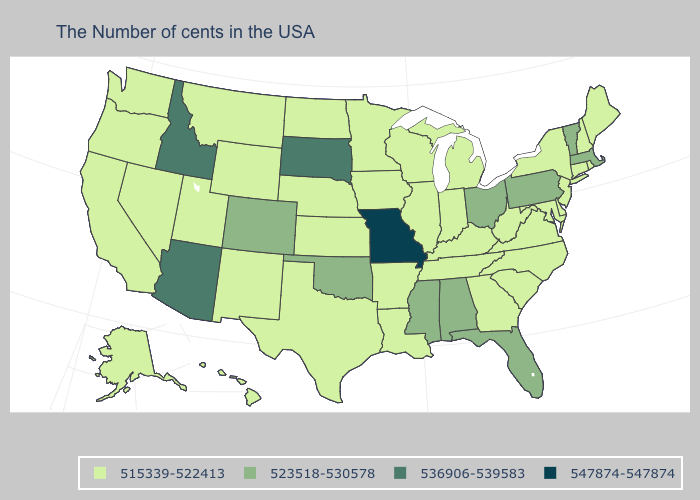Does Missouri have the highest value in the MidWest?
Be succinct. Yes. How many symbols are there in the legend?
Write a very short answer. 4. Does Texas have the same value as Arizona?
Give a very brief answer. No. Does the map have missing data?
Write a very short answer. No. Which states have the lowest value in the South?
Be succinct. Delaware, Maryland, Virginia, North Carolina, South Carolina, West Virginia, Georgia, Kentucky, Tennessee, Louisiana, Arkansas, Texas. Does Oklahoma have the highest value in the South?
Write a very short answer. Yes. Does Missouri have the highest value in the USA?
Answer briefly. Yes. Name the states that have a value in the range 523518-530578?
Write a very short answer. Massachusetts, Vermont, Pennsylvania, Ohio, Florida, Alabama, Mississippi, Oklahoma, Colorado. Does Louisiana have the lowest value in the South?
Quick response, please. Yes. Name the states that have a value in the range 536906-539583?
Write a very short answer. South Dakota, Arizona, Idaho. Does Mississippi have a lower value than Montana?
Quick response, please. No. Name the states that have a value in the range 547874-547874?
Answer briefly. Missouri. What is the value of Arkansas?
Answer briefly. 515339-522413. What is the value of Hawaii?
Concise answer only. 515339-522413. 